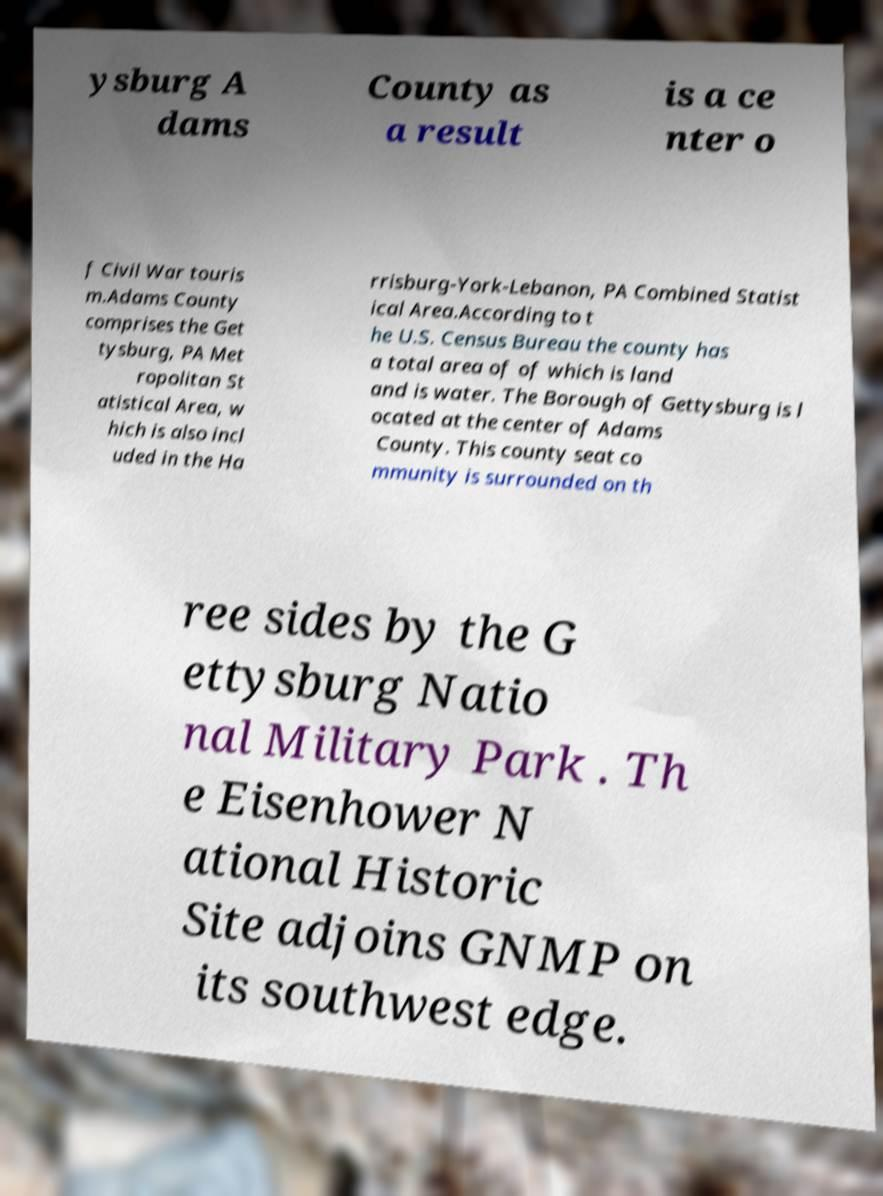I need the written content from this picture converted into text. Can you do that? ysburg A dams County as a result is a ce nter o f Civil War touris m.Adams County comprises the Get tysburg, PA Met ropolitan St atistical Area, w hich is also incl uded in the Ha rrisburg-York-Lebanon, PA Combined Statist ical Area.According to t he U.S. Census Bureau the county has a total area of of which is land and is water. The Borough of Gettysburg is l ocated at the center of Adams County. This county seat co mmunity is surrounded on th ree sides by the G ettysburg Natio nal Military Park . Th e Eisenhower N ational Historic Site adjoins GNMP on its southwest edge. 